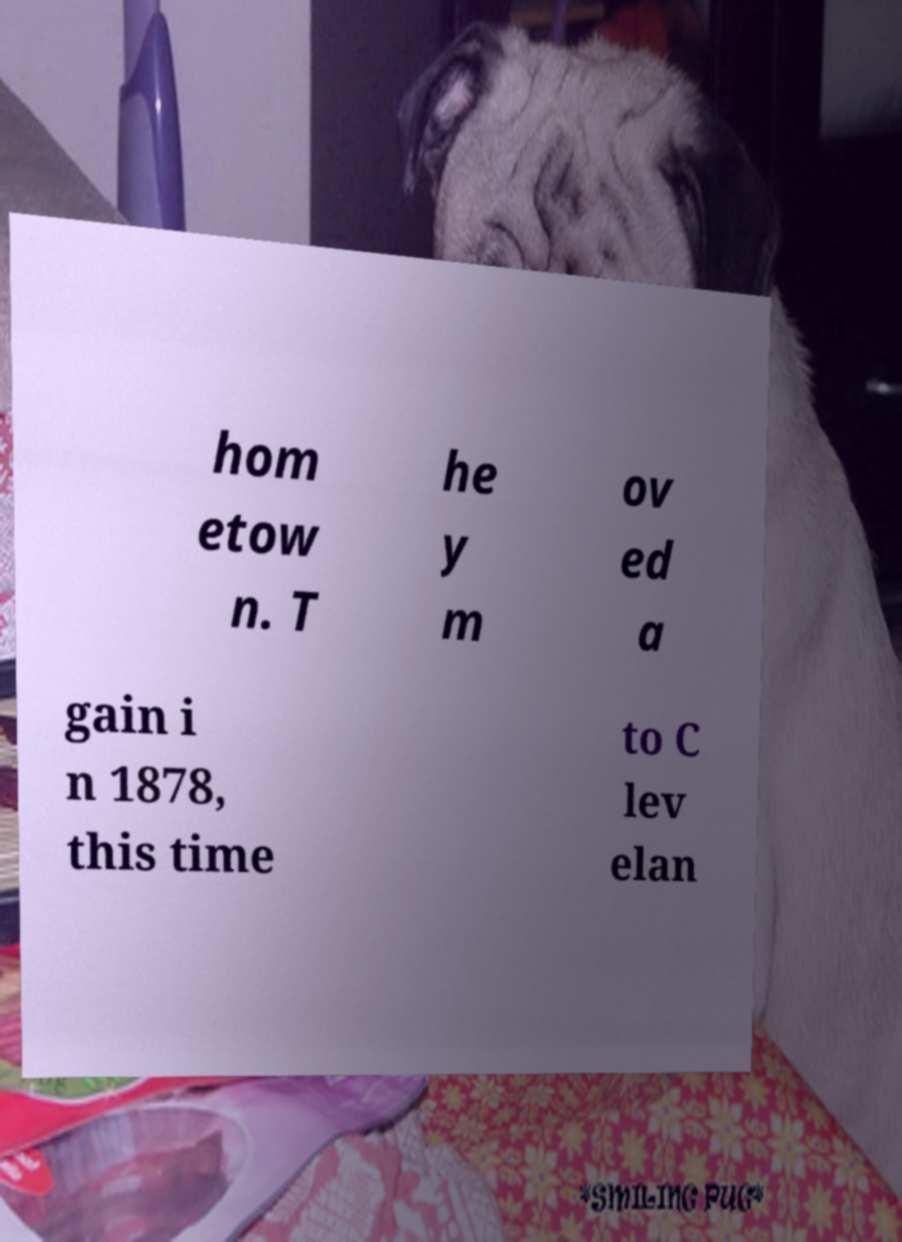Can you accurately transcribe the text from the provided image for me? hom etow n. T he y m ov ed a gain i n 1878, this time to C lev elan 